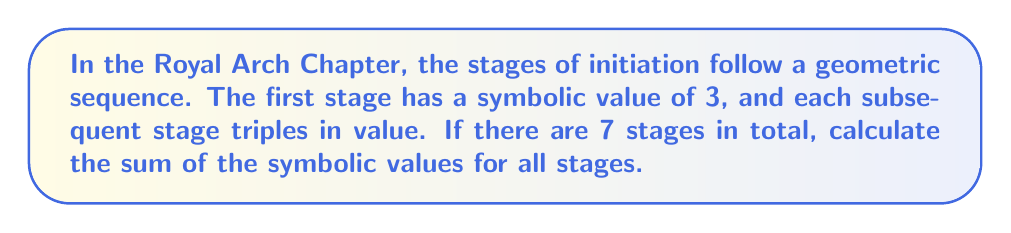Solve this math problem. Let's approach this step-by-step:

1) We have a geometric sequence with:
   - First term, $a = 3$
   - Common ratio, $r = 3$
   - Number of terms, $n = 7$

2) The formula for the sum of a geometric sequence is:

   $$S_n = \frac{a(1-r^n)}{1-r}$$

   Where $S_n$ is the sum of $n$ terms.

3) Substituting our values:

   $$S_7 = \frac{3(1-3^7)}{1-3}$$

4) Simplify the numerator:
   $$3^7 = 2187$$
   $$1 - 3^7 = 1 - 2187 = -2186$$

5) Now our equation looks like:

   $$S_7 = \frac{3(-2186)}{-2}$$

6) Simplify:
   $$S_7 = \frac{-6558}{-2} = 3279$$

Therefore, the sum of the symbolic values for all 7 stages is 3279.
Answer: 3279 